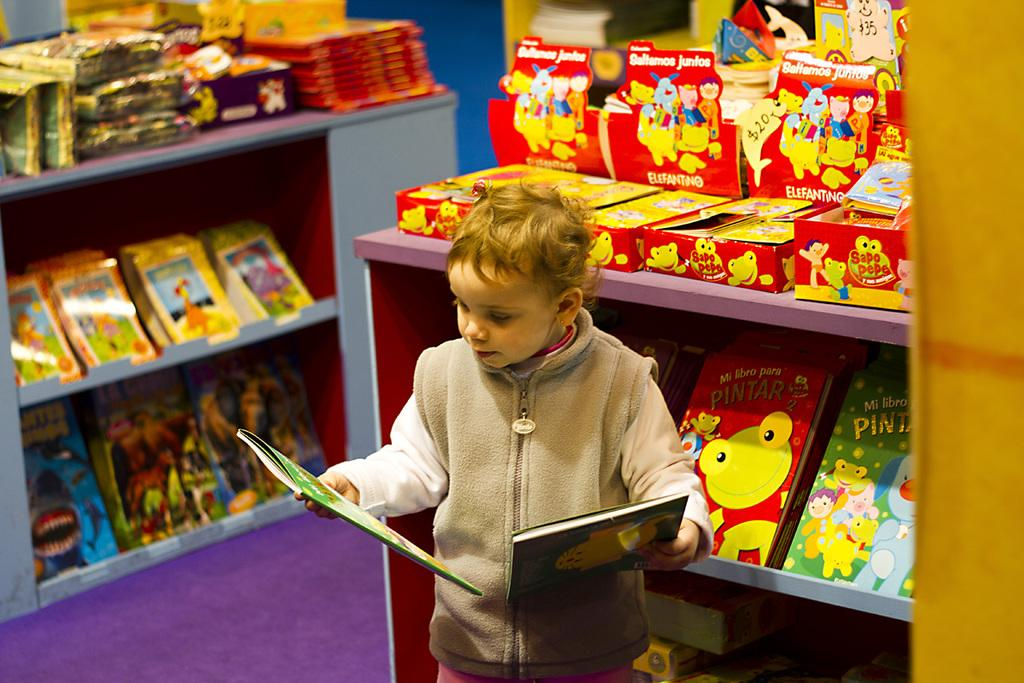<image>
Render a clear and concise summary of the photo. A little boy holds books in front of one titled Pintar. 